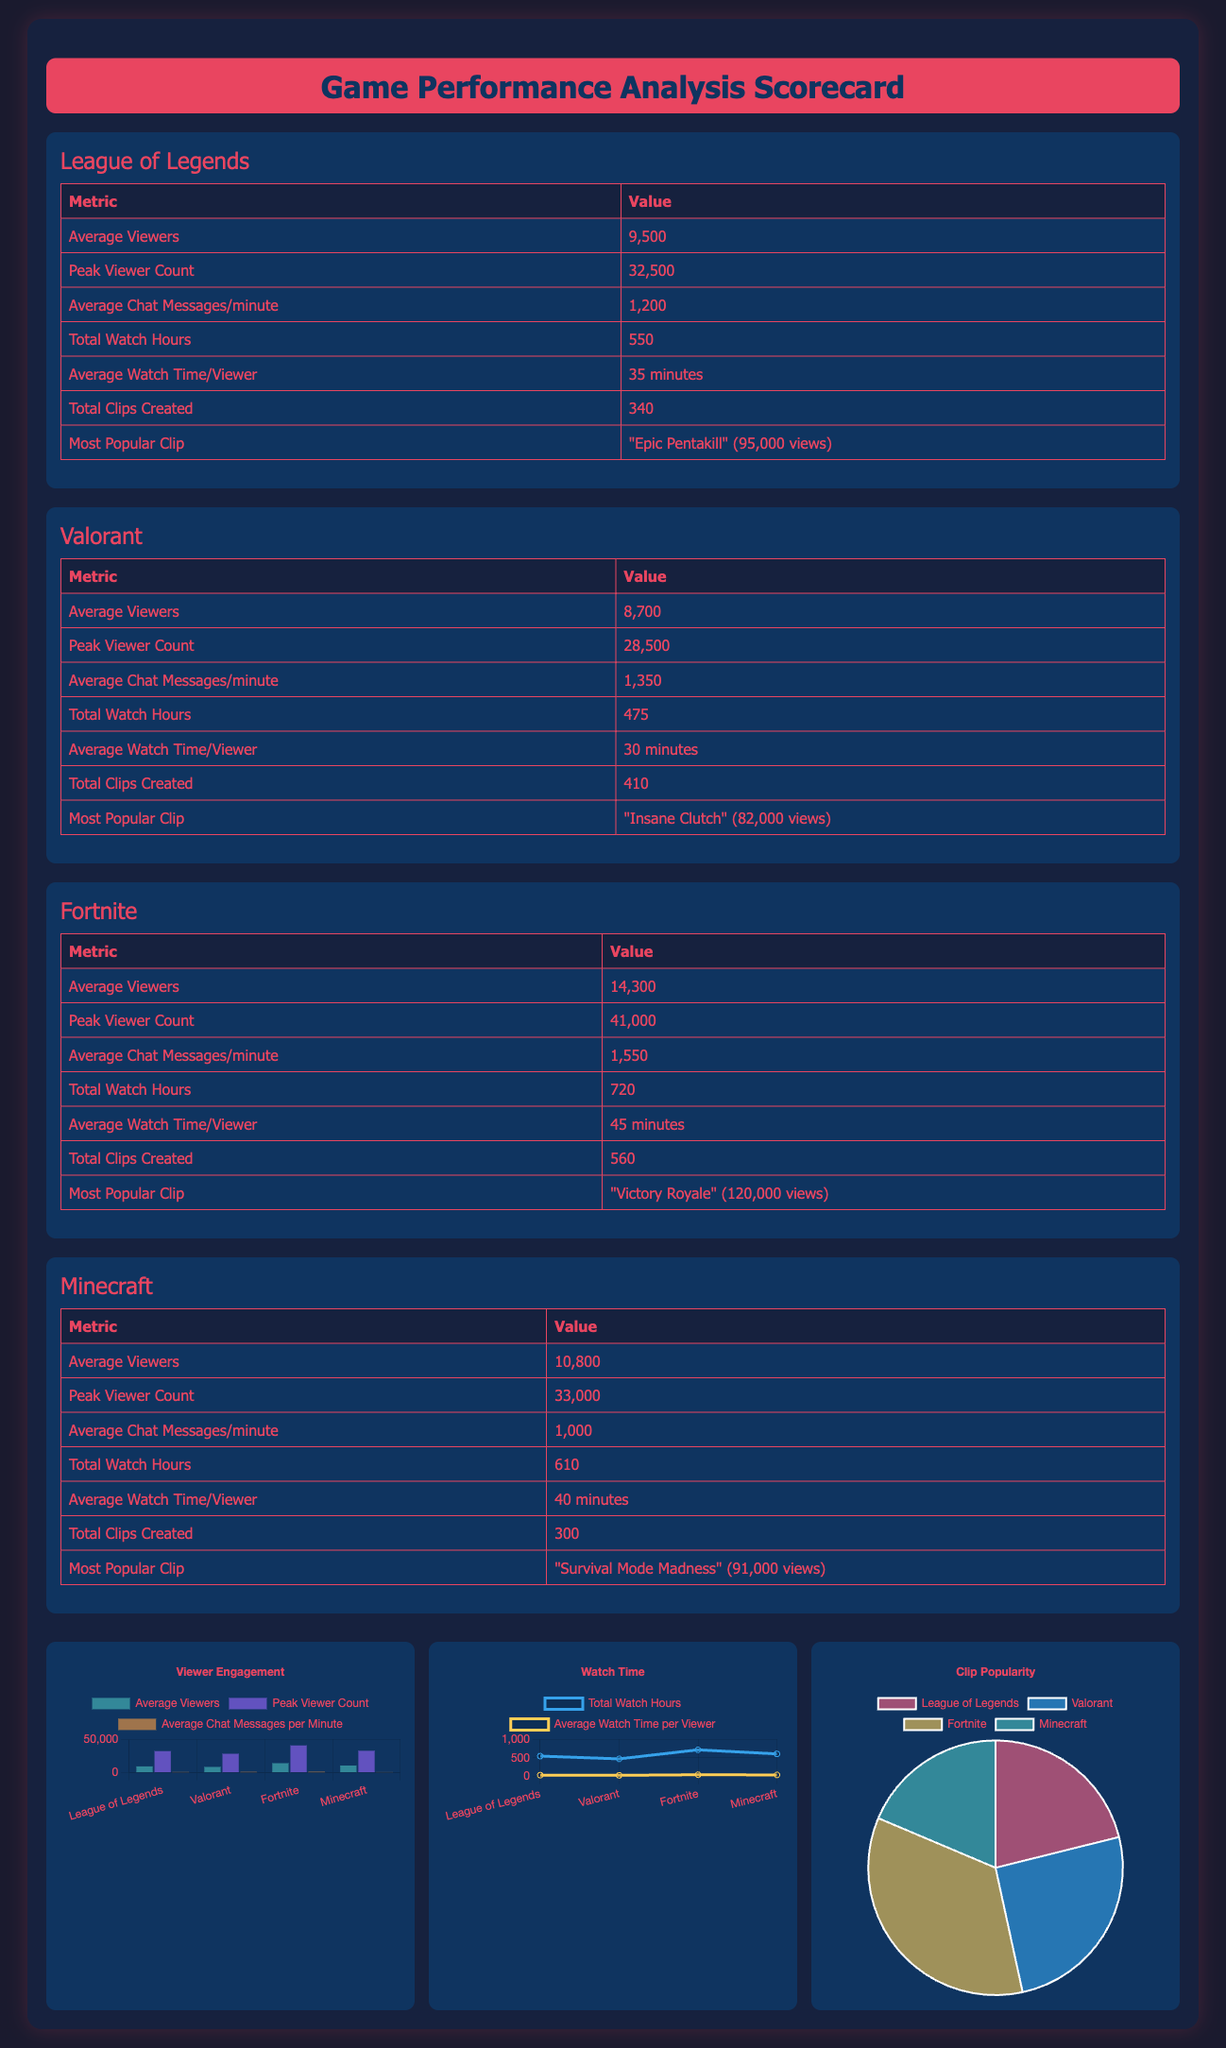What is the average viewer count for Fortnite? The average viewer count for Fortnite is specified in the scorecard.
Answer: 14,300 Which game had the highest peak viewer count? Comparing the peak viewer counts listed for each game, Fortnite has the highest value.
Answer: Fortnite How many total clips were created for Valorant? The scorecard explicitly states the number of clips created for Valorant.
Answer: 410 What is the most popular clip for League of Legends? The most popular clip for League of Legends is indicated in the document.
Answer: "Epic Pentakill" (95,000 views) What is the average watch time per viewer for Minecraft? The scorecard contains the average watch time per viewer for Minecraft.
Answer: 40 minutes Which game had the most average chat messages per minute? Examining the average chat messages per minute shows that Fortnite had the highest count.
Answer: Fortnite What is the total watch hours for League of Legends? The total watch hours for League of Legends is provided in the scorecard.
Answer: 550 Which game has the lowest average viewers? By reviewing the average viewers for each game, Valorant shows the lowest average.
Answer: Valorant What type of chart is used to represent clip popularity? The scorecard describes the type of visualization used for displaying clip popularity.
Answer: Pie chart 